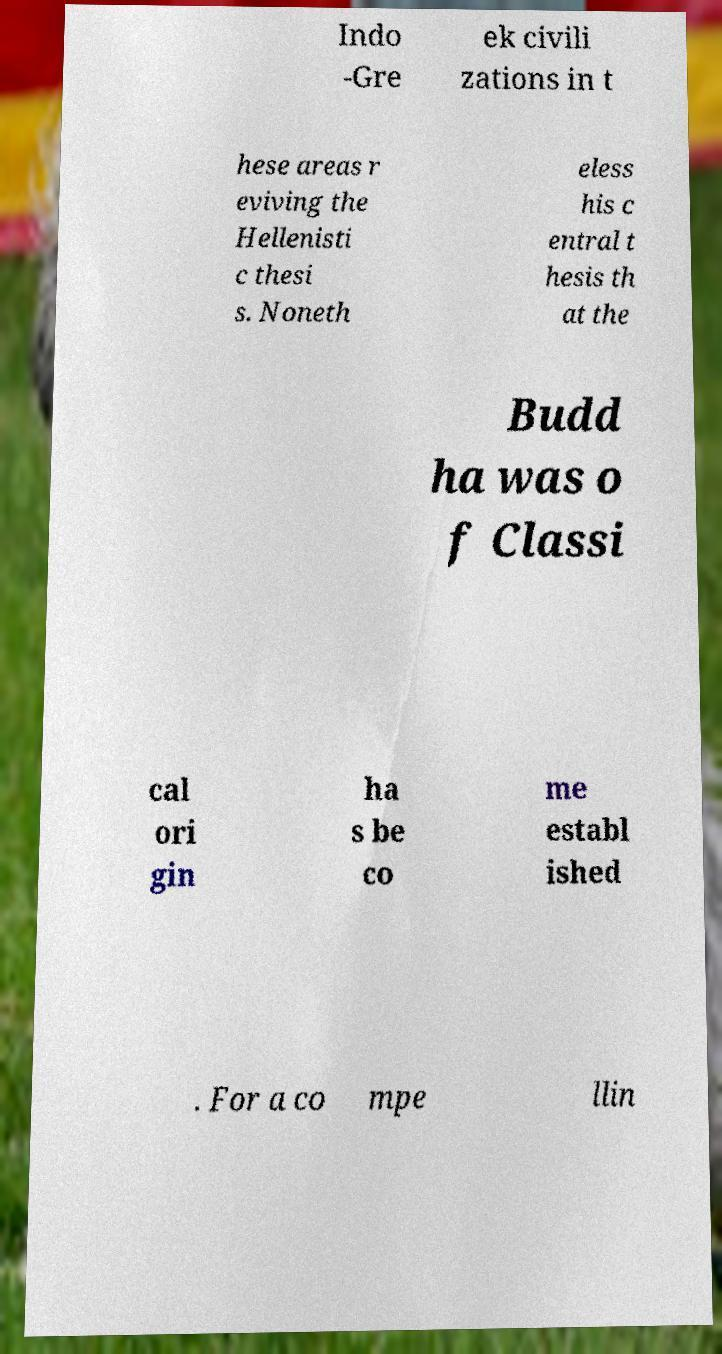Could you extract and type out the text from this image? Indo -Gre ek civili zations in t hese areas r eviving the Hellenisti c thesi s. Noneth eless his c entral t hesis th at the Budd ha was o f Classi cal ori gin ha s be co me establ ished . For a co mpe llin 